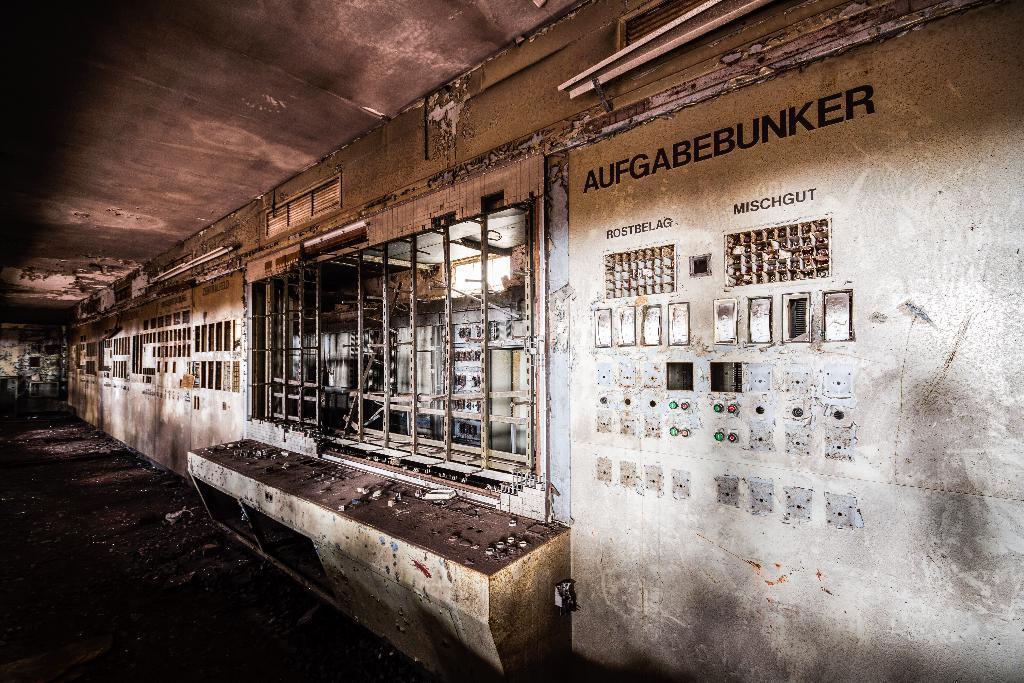Please provide a concise description of this image. In this picture, we see a wall on which buttons are placed. We see some text written on the wall. Beside that, we see a window. At the top of the picture, we see the ceiling of the room. This picture might be clicked in the industry or a factory. 